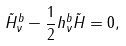<formula> <loc_0><loc_0><loc_500><loc_500>\tilde { H } _ { \nu } ^ { b } - \frac { 1 } { 2 } h _ { \nu } ^ { b } \tilde { H } = 0 ,</formula> 